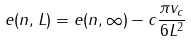<formula> <loc_0><loc_0><loc_500><loc_500>e ( n , L ) = e ( n , \infty ) - c \frac { \pi v _ { c } } { 6 L ^ { 2 } }</formula> 